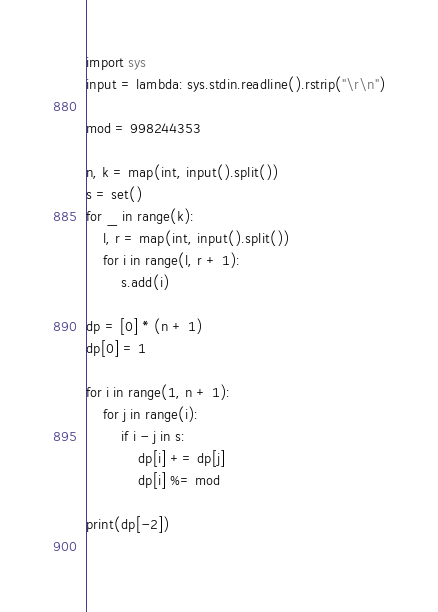Convert code to text. <code><loc_0><loc_0><loc_500><loc_500><_Python_>import sys
input = lambda: sys.stdin.readline().rstrip("\r\n")

mod = 998244353

n, k = map(int, input().split())
s = set()
for _ in range(k):
    l, r = map(int, input().split())
    for i in range(l, r + 1):
        s.add(i)

dp = [0] * (n + 1)
dp[0] = 1

for i in range(1, n + 1):
    for j in range(i):
        if i - j in s:
            dp[i] += dp[j]
            dp[i] %= mod

print(dp[-2])
    </code> 